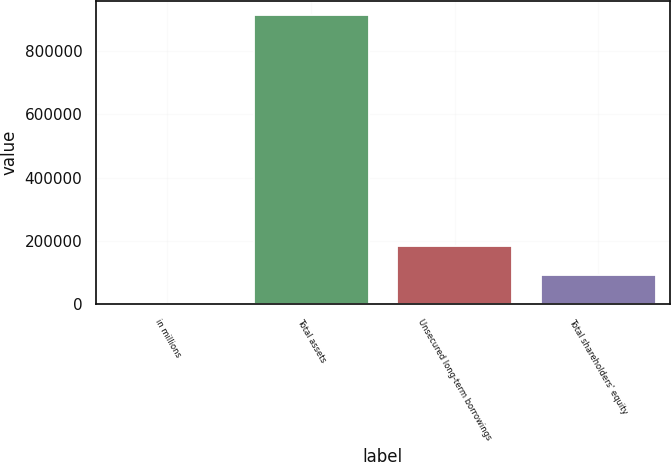<chart> <loc_0><loc_0><loc_500><loc_500><bar_chart><fcel>in millions<fcel>Total assets<fcel>Unsecured long-term borrowings<fcel>Total shareholders' equity<nl><fcel>2013<fcel>911507<fcel>183912<fcel>92962.4<nl></chart> 